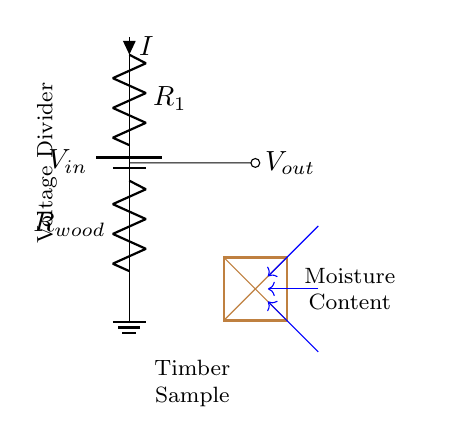What is the input voltage in the circuit? The input voltage is represented by the symbol V_{in} at the top of the circuit, indicating the supply voltage.
Answer: V_{in} What is the resistance of the wood? The resistance of the wood is shown as R_{wood} in the circuit diagram, indicating it is a variable resistor that changes with moisture content.
Answer: R_{wood} What type of circuit is represented? The circuit is a voltage divider, which is a specific type of circuit used to produce an output voltage that is a fraction of the input voltage.
Answer: Voltage Divider What is the direction of current flow in the circuit? The current, represented by the symbol I, flows downwards from the input through both resistors R_1 and R_{wood}, as indicated by the arrow next to I.
Answer: Downwards What can affect the value of V_{out}? The value of V_{out} depends on the resistances of R_1 and R_{wood}, specifically the changing resistance of R_{wood} due to different moisture contents in the timber.
Answer: Moisture Content How does the moisture content influence the output voltage? As moisture content increases, the resistance R_{wood} typically decreases, which changes the voltage drop across it and affects V_{out} according to the voltage divider formula.
Answer: Decreases R_{wood} 